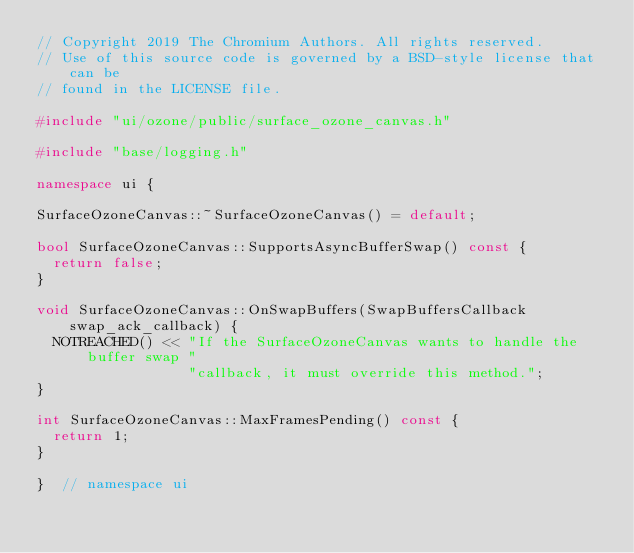<code> <loc_0><loc_0><loc_500><loc_500><_C++_>// Copyright 2019 The Chromium Authors. All rights reserved.
// Use of this source code is governed by a BSD-style license that can be
// found in the LICENSE file.

#include "ui/ozone/public/surface_ozone_canvas.h"

#include "base/logging.h"

namespace ui {

SurfaceOzoneCanvas::~SurfaceOzoneCanvas() = default;

bool SurfaceOzoneCanvas::SupportsAsyncBufferSwap() const {
  return false;
}

void SurfaceOzoneCanvas::OnSwapBuffers(SwapBuffersCallback swap_ack_callback) {
  NOTREACHED() << "If the SurfaceOzoneCanvas wants to handle the buffer swap "
                  "callback, it must override this method.";
}

int SurfaceOzoneCanvas::MaxFramesPending() const {
  return 1;
}

}  // namespace ui
</code> 